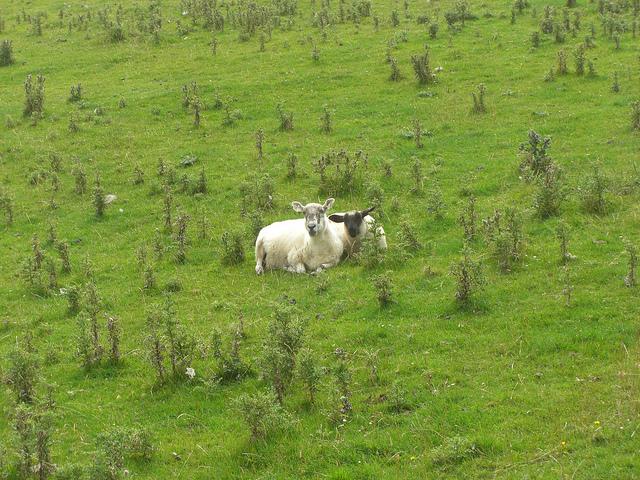What is the weather like in this picture?
Be succinct. Sunny. What white stuff is on the ground?
Give a very brief answer. Sheep. Can the animals eat the plants in the picture?
Concise answer only. Yes. What is the difference between the two animals?
Give a very brief answer. Face color. What kind of animals are laying in the field?
Write a very short answer. Sheep. Are the animals in the picture identical?
Write a very short answer. No. 